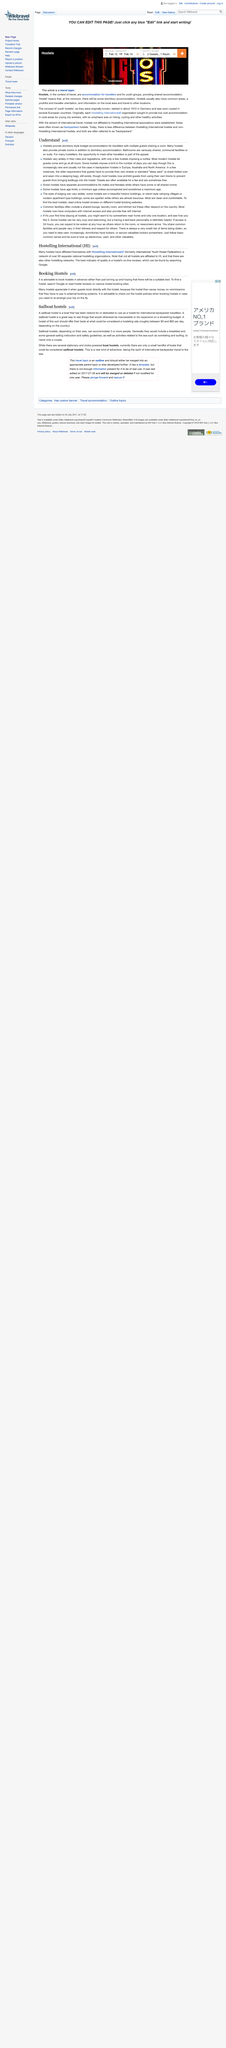Highlight a few significant elements in this photo. The best way to determine which hostel to stay at is by reading online hostel reviews and comparing different hostel booking websites. Booking directly with the hostel helps the hostel by saving them money on the commissions paid to external booking systems, as the hostel is able to keep the full amount of the booking. It is possible for individuals of any age and gender to stay in the same hostel, but the availability of such options may vary depending on the specific establishment. Some hostels may impose restrictions, while others do not. Hostels are able to offer cheaper rates than traditional lodging because they allow multiple travelers to stay in the same room, thereby reducing the cost per person. There are both stationary and motor-powered sail boat hostels, and no, they do not move. 